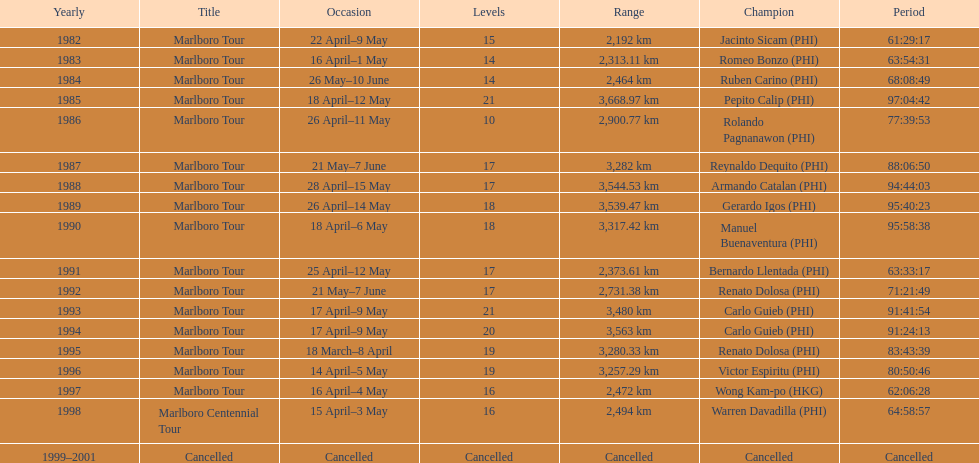I'm looking to parse the entire table for insights. Could you assist me with that? {'header': ['Yearly', 'Title', 'Occasion', 'Levels', 'Range', 'Champion', 'Period'], 'rows': [['1982', 'Marlboro Tour', '22 April–9 May', '15', '2,192\xa0km', 'Jacinto Sicam\xa0(PHI)', '61:29:17'], ['1983', 'Marlboro Tour', '16 April–1 May', '14', '2,313.11\xa0km', 'Romeo Bonzo\xa0(PHI)', '63:54:31'], ['1984', 'Marlboro Tour', '26 May–10 June', '14', '2,464\xa0km', 'Ruben Carino\xa0(PHI)', '68:08:49'], ['1985', 'Marlboro Tour', '18 April–12 May', '21', '3,668.97\xa0km', 'Pepito Calip\xa0(PHI)', '97:04:42'], ['1986', 'Marlboro Tour', '26 April–11 May', '10', '2,900.77\xa0km', 'Rolando Pagnanawon\xa0(PHI)', '77:39:53'], ['1987', 'Marlboro Tour', '21 May–7 June', '17', '3,282\xa0km', 'Reynaldo Dequito\xa0(PHI)', '88:06:50'], ['1988', 'Marlboro Tour', '28 April–15 May', '17', '3,544.53\xa0km', 'Armando Catalan\xa0(PHI)', '94:44:03'], ['1989', 'Marlboro Tour', '26 April–14 May', '18', '3,539.47\xa0km', 'Gerardo Igos\xa0(PHI)', '95:40:23'], ['1990', 'Marlboro Tour', '18 April–6 May', '18', '3,317.42\xa0km', 'Manuel Buenaventura\xa0(PHI)', '95:58:38'], ['1991', 'Marlboro Tour', '25 April–12 May', '17', '2,373.61\xa0km', 'Bernardo Llentada\xa0(PHI)', '63:33:17'], ['1992', 'Marlboro Tour', '21 May–7 June', '17', '2,731.38\xa0km', 'Renato Dolosa\xa0(PHI)', '71:21:49'], ['1993', 'Marlboro Tour', '17 April–9 May', '21', '3,480\xa0km', 'Carlo Guieb\xa0(PHI)', '91:41:54'], ['1994', 'Marlboro Tour', '17 April–9 May', '20', '3,563\xa0km', 'Carlo Guieb\xa0(PHI)', '91:24:13'], ['1995', 'Marlboro Tour', '18 March–8 April', '19', '3,280.33\xa0km', 'Renato Dolosa\xa0(PHI)', '83:43:39'], ['1996', 'Marlboro Tour', '14 April–5 May', '19', '3,257.29\xa0km', 'Victor Espiritu\xa0(PHI)', '80:50:46'], ['1997', 'Marlboro Tour', '16 April–4 May', '16', '2,472\xa0km', 'Wong Kam-po\xa0(HKG)', '62:06:28'], ['1998', 'Marlboro Centennial Tour', '15 April–3 May', '16', '2,494\xa0km', 'Warren Davadilla\xa0(PHI)', '64:58:57'], ['1999–2001', 'Cancelled', 'Cancelled', 'Cancelled', 'Cancelled', 'Cancelled', 'Cancelled']]} How long did it take warren davadilla to complete the 1998 marlboro centennial tour? 64:58:57. 